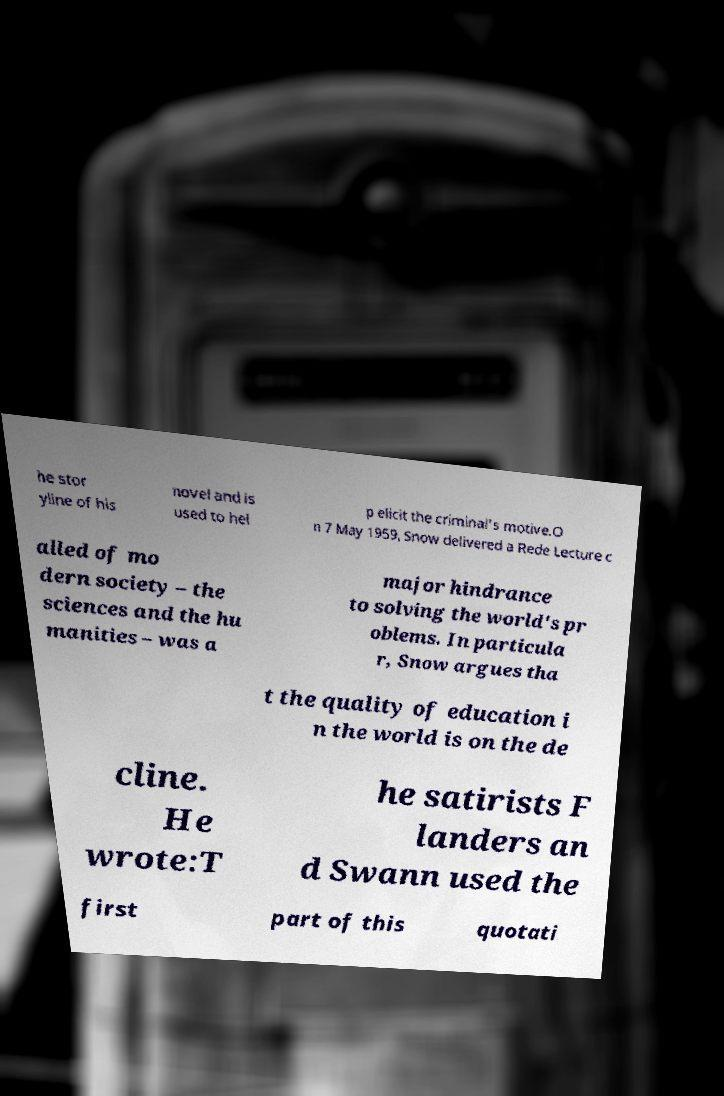There's text embedded in this image that I need extracted. Can you transcribe it verbatim? he stor yline of his novel and is used to hel p elicit the criminal's motive.O n 7 May 1959, Snow delivered a Rede Lecture c alled of mo dern society – the sciences and the hu manities – was a major hindrance to solving the world's pr oblems. In particula r, Snow argues tha t the quality of education i n the world is on the de cline. He wrote:T he satirists F landers an d Swann used the first part of this quotati 